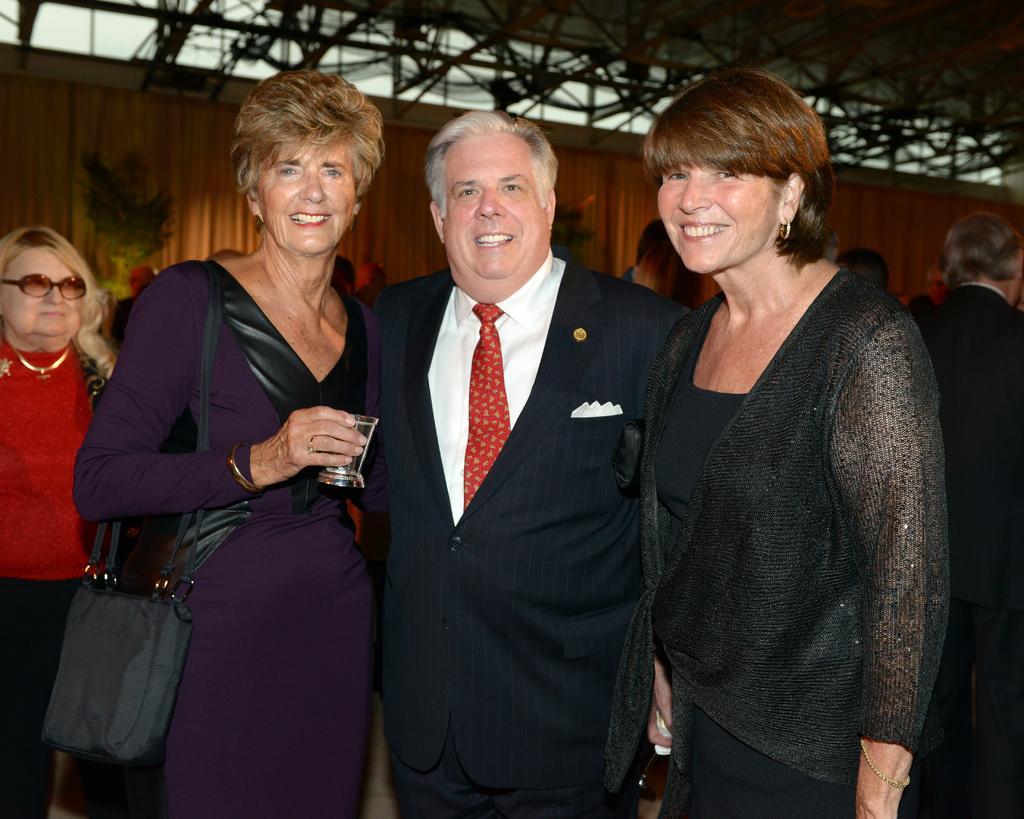Can you describe this image briefly? In this image I can see three persons standing. The person at right wearing black color dress, the person in the middle wearing black blazer, white shirt, red color tie, and the person at left wearing purple color dress. Background I can see the other person standing and a wooden wall and the sky is in white color. 